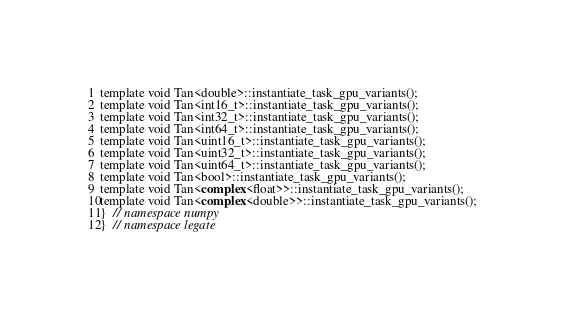<code> <loc_0><loc_0><loc_500><loc_500><_Cuda_>template void Tan<double>::instantiate_task_gpu_variants();
template void Tan<int16_t>::instantiate_task_gpu_variants();
template void Tan<int32_t>::instantiate_task_gpu_variants();
template void Tan<int64_t>::instantiate_task_gpu_variants();
template void Tan<uint16_t>::instantiate_task_gpu_variants();
template void Tan<uint32_t>::instantiate_task_gpu_variants();
template void Tan<uint64_t>::instantiate_task_gpu_variants();
template void Tan<bool>::instantiate_task_gpu_variants();
template void Tan<complex<float>>::instantiate_task_gpu_variants();
template void Tan<complex<double>>::instantiate_task_gpu_variants();
}  // namespace numpy
}  // namespace legate
</code> 